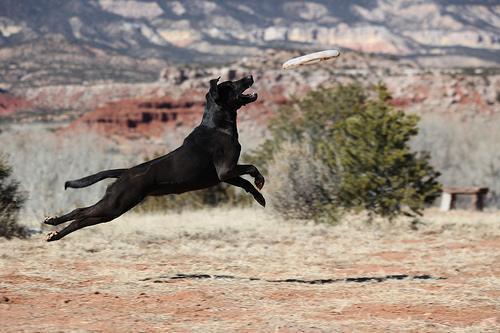How many dogs are in the picture?
Give a very brief answer. 1. 